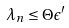<formula> <loc_0><loc_0><loc_500><loc_500>\lambda _ { n } \leq \Theta \epsilon ^ { \prime }</formula> 